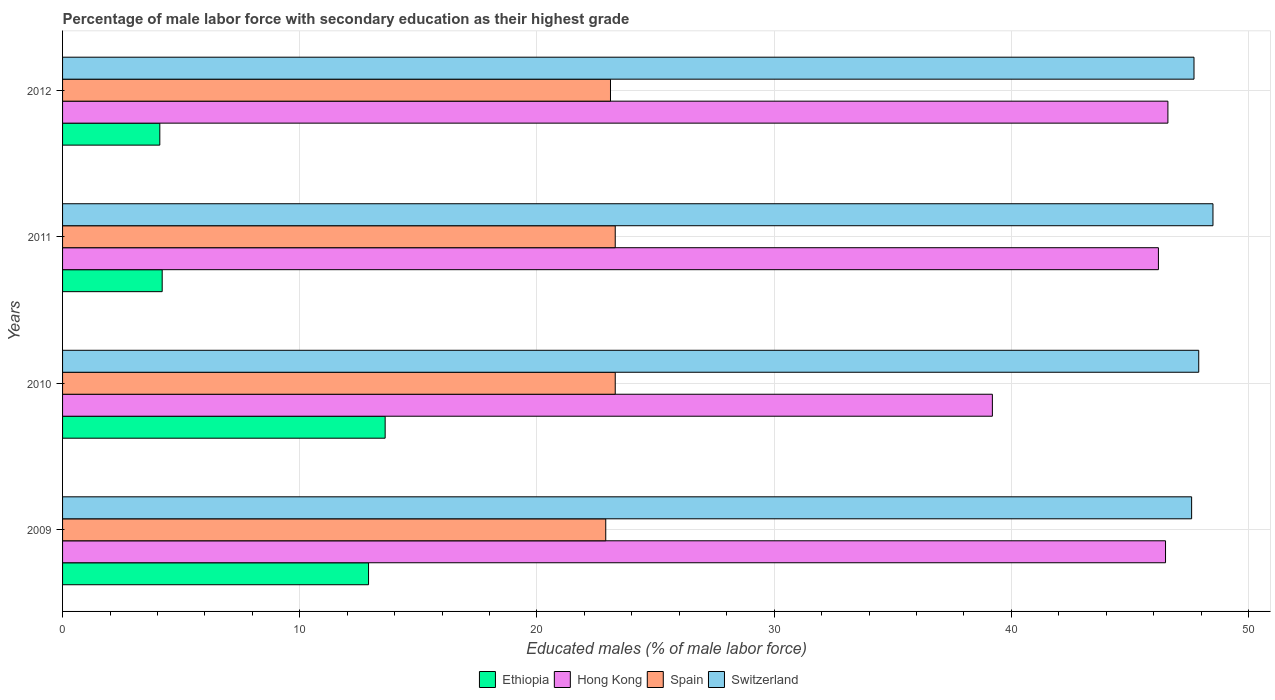How many different coloured bars are there?
Offer a very short reply. 4. Are the number of bars on each tick of the Y-axis equal?
Ensure brevity in your answer.  Yes. How many bars are there on the 4th tick from the top?
Give a very brief answer. 4. What is the label of the 3rd group of bars from the top?
Keep it short and to the point. 2010. In how many cases, is the number of bars for a given year not equal to the number of legend labels?
Give a very brief answer. 0. What is the percentage of male labor force with secondary education in Ethiopia in 2011?
Give a very brief answer. 4.2. Across all years, what is the maximum percentage of male labor force with secondary education in Spain?
Offer a very short reply. 23.3. Across all years, what is the minimum percentage of male labor force with secondary education in Switzerland?
Keep it short and to the point. 47.6. In which year was the percentage of male labor force with secondary education in Hong Kong maximum?
Offer a terse response. 2012. In which year was the percentage of male labor force with secondary education in Switzerland minimum?
Provide a short and direct response. 2009. What is the total percentage of male labor force with secondary education in Ethiopia in the graph?
Keep it short and to the point. 34.8. What is the difference between the percentage of male labor force with secondary education in Ethiopia in 2009 and that in 2012?
Offer a very short reply. 8.8. What is the difference between the percentage of male labor force with secondary education in Ethiopia in 2011 and the percentage of male labor force with secondary education in Spain in 2012?
Offer a very short reply. -18.9. What is the average percentage of male labor force with secondary education in Hong Kong per year?
Keep it short and to the point. 44.63. In the year 2011, what is the difference between the percentage of male labor force with secondary education in Switzerland and percentage of male labor force with secondary education in Hong Kong?
Your answer should be compact. 2.3. What is the difference between the highest and the second highest percentage of male labor force with secondary education in Ethiopia?
Your answer should be compact. 0.7. What is the difference between the highest and the lowest percentage of male labor force with secondary education in Spain?
Offer a terse response. 0.4. In how many years, is the percentage of male labor force with secondary education in Spain greater than the average percentage of male labor force with secondary education in Spain taken over all years?
Provide a short and direct response. 2. Is it the case that in every year, the sum of the percentage of male labor force with secondary education in Ethiopia and percentage of male labor force with secondary education in Spain is greater than the sum of percentage of male labor force with secondary education in Hong Kong and percentage of male labor force with secondary education in Switzerland?
Make the answer very short. No. What does the 4th bar from the top in 2010 represents?
Provide a short and direct response. Ethiopia. Is it the case that in every year, the sum of the percentage of male labor force with secondary education in Hong Kong and percentage of male labor force with secondary education in Spain is greater than the percentage of male labor force with secondary education in Ethiopia?
Your response must be concise. Yes. How many bars are there?
Your answer should be very brief. 16. How many years are there in the graph?
Make the answer very short. 4. What is the difference between two consecutive major ticks on the X-axis?
Offer a very short reply. 10. Are the values on the major ticks of X-axis written in scientific E-notation?
Provide a short and direct response. No. Does the graph contain any zero values?
Your response must be concise. No. How many legend labels are there?
Your response must be concise. 4. How are the legend labels stacked?
Provide a short and direct response. Horizontal. What is the title of the graph?
Your answer should be compact. Percentage of male labor force with secondary education as their highest grade. What is the label or title of the X-axis?
Your answer should be compact. Educated males (% of male labor force). What is the label or title of the Y-axis?
Your response must be concise. Years. What is the Educated males (% of male labor force) of Ethiopia in 2009?
Offer a very short reply. 12.9. What is the Educated males (% of male labor force) of Hong Kong in 2009?
Make the answer very short. 46.5. What is the Educated males (% of male labor force) in Spain in 2009?
Offer a very short reply. 22.9. What is the Educated males (% of male labor force) in Switzerland in 2009?
Give a very brief answer. 47.6. What is the Educated males (% of male labor force) in Ethiopia in 2010?
Provide a succinct answer. 13.6. What is the Educated males (% of male labor force) of Hong Kong in 2010?
Your answer should be very brief. 39.2. What is the Educated males (% of male labor force) in Spain in 2010?
Provide a short and direct response. 23.3. What is the Educated males (% of male labor force) in Switzerland in 2010?
Your answer should be compact. 47.9. What is the Educated males (% of male labor force) in Ethiopia in 2011?
Offer a very short reply. 4.2. What is the Educated males (% of male labor force) in Hong Kong in 2011?
Your response must be concise. 46.2. What is the Educated males (% of male labor force) of Spain in 2011?
Your response must be concise. 23.3. What is the Educated males (% of male labor force) in Switzerland in 2011?
Your answer should be very brief. 48.5. What is the Educated males (% of male labor force) in Ethiopia in 2012?
Your answer should be very brief. 4.1. What is the Educated males (% of male labor force) of Hong Kong in 2012?
Your answer should be very brief. 46.6. What is the Educated males (% of male labor force) of Spain in 2012?
Your response must be concise. 23.1. What is the Educated males (% of male labor force) of Switzerland in 2012?
Give a very brief answer. 47.7. Across all years, what is the maximum Educated males (% of male labor force) in Ethiopia?
Your answer should be compact. 13.6. Across all years, what is the maximum Educated males (% of male labor force) in Hong Kong?
Offer a very short reply. 46.6. Across all years, what is the maximum Educated males (% of male labor force) in Spain?
Offer a very short reply. 23.3. Across all years, what is the maximum Educated males (% of male labor force) of Switzerland?
Make the answer very short. 48.5. Across all years, what is the minimum Educated males (% of male labor force) of Ethiopia?
Your response must be concise. 4.1. Across all years, what is the minimum Educated males (% of male labor force) in Hong Kong?
Give a very brief answer. 39.2. Across all years, what is the minimum Educated males (% of male labor force) in Spain?
Keep it short and to the point. 22.9. Across all years, what is the minimum Educated males (% of male labor force) of Switzerland?
Provide a succinct answer. 47.6. What is the total Educated males (% of male labor force) in Ethiopia in the graph?
Offer a very short reply. 34.8. What is the total Educated males (% of male labor force) in Hong Kong in the graph?
Your answer should be compact. 178.5. What is the total Educated males (% of male labor force) of Spain in the graph?
Ensure brevity in your answer.  92.6. What is the total Educated males (% of male labor force) of Switzerland in the graph?
Provide a succinct answer. 191.7. What is the difference between the Educated males (% of male labor force) of Ethiopia in 2009 and that in 2010?
Give a very brief answer. -0.7. What is the difference between the Educated males (% of male labor force) of Hong Kong in 2009 and that in 2010?
Your answer should be compact. 7.3. What is the difference between the Educated males (% of male labor force) in Switzerland in 2009 and that in 2010?
Offer a terse response. -0.3. What is the difference between the Educated males (% of male labor force) in Ethiopia in 2009 and that in 2011?
Make the answer very short. 8.7. What is the difference between the Educated males (% of male labor force) of Hong Kong in 2009 and that in 2011?
Your answer should be very brief. 0.3. What is the difference between the Educated males (% of male labor force) in Switzerland in 2009 and that in 2011?
Offer a very short reply. -0.9. What is the difference between the Educated males (% of male labor force) of Ethiopia in 2009 and that in 2012?
Keep it short and to the point. 8.8. What is the difference between the Educated males (% of male labor force) of Hong Kong in 2009 and that in 2012?
Ensure brevity in your answer.  -0.1. What is the difference between the Educated males (% of male labor force) of Switzerland in 2009 and that in 2012?
Make the answer very short. -0.1. What is the difference between the Educated males (% of male labor force) in Ethiopia in 2010 and that in 2011?
Keep it short and to the point. 9.4. What is the difference between the Educated males (% of male labor force) of Hong Kong in 2010 and that in 2011?
Your answer should be compact. -7. What is the difference between the Educated males (% of male labor force) in Spain in 2010 and that in 2011?
Make the answer very short. 0. What is the difference between the Educated males (% of male labor force) of Ethiopia in 2010 and that in 2012?
Keep it short and to the point. 9.5. What is the difference between the Educated males (% of male labor force) of Hong Kong in 2010 and that in 2012?
Your answer should be compact. -7.4. What is the difference between the Educated males (% of male labor force) in Spain in 2010 and that in 2012?
Provide a short and direct response. 0.2. What is the difference between the Educated males (% of male labor force) of Switzerland in 2010 and that in 2012?
Make the answer very short. 0.2. What is the difference between the Educated males (% of male labor force) in Spain in 2011 and that in 2012?
Keep it short and to the point. 0.2. What is the difference between the Educated males (% of male labor force) of Ethiopia in 2009 and the Educated males (% of male labor force) of Hong Kong in 2010?
Keep it short and to the point. -26.3. What is the difference between the Educated males (% of male labor force) in Ethiopia in 2009 and the Educated males (% of male labor force) in Spain in 2010?
Your answer should be compact. -10.4. What is the difference between the Educated males (% of male labor force) in Ethiopia in 2009 and the Educated males (% of male labor force) in Switzerland in 2010?
Offer a very short reply. -35. What is the difference between the Educated males (% of male labor force) in Hong Kong in 2009 and the Educated males (% of male labor force) in Spain in 2010?
Provide a short and direct response. 23.2. What is the difference between the Educated males (% of male labor force) of Hong Kong in 2009 and the Educated males (% of male labor force) of Switzerland in 2010?
Your answer should be compact. -1.4. What is the difference between the Educated males (% of male labor force) in Spain in 2009 and the Educated males (% of male labor force) in Switzerland in 2010?
Give a very brief answer. -25. What is the difference between the Educated males (% of male labor force) of Ethiopia in 2009 and the Educated males (% of male labor force) of Hong Kong in 2011?
Your answer should be very brief. -33.3. What is the difference between the Educated males (% of male labor force) of Ethiopia in 2009 and the Educated males (% of male labor force) of Spain in 2011?
Keep it short and to the point. -10.4. What is the difference between the Educated males (% of male labor force) in Ethiopia in 2009 and the Educated males (% of male labor force) in Switzerland in 2011?
Ensure brevity in your answer.  -35.6. What is the difference between the Educated males (% of male labor force) in Hong Kong in 2009 and the Educated males (% of male labor force) in Spain in 2011?
Make the answer very short. 23.2. What is the difference between the Educated males (% of male labor force) of Spain in 2009 and the Educated males (% of male labor force) of Switzerland in 2011?
Your answer should be very brief. -25.6. What is the difference between the Educated males (% of male labor force) of Ethiopia in 2009 and the Educated males (% of male labor force) of Hong Kong in 2012?
Offer a very short reply. -33.7. What is the difference between the Educated males (% of male labor force) in Ethiopia in 2009 and the Educated males (% of male labor force) in Spain in 2012?
Provide a short and direct response. -10.2. What is the difference between the Educated males (% of male labor force) of Ethiopia in 2009 and the Educated males (% of male labor force) of Switzerland in 2012?
Provide a short and direct response. -34.8. What is the difference between the Educated males (% of male labor force) of Hong Kong in 2009 and the Educated males (% of male labor force) of Spain in 2012?
Make the answer very short. 23.4. What is the difference between the Educated males (% of male labor force) of Spain in 2009 and the Educated males (% of male labor force) of Switzerland in 2012?
Offer a terse response. -24.8. What is the difference between the Educated males (% of male labor force) in Ethiopia in 2010 and the Educated males (% of male labor force) in Hong Kong in 2011?
Offer a terse response. -32.6. What is the difference between the Educated males (% of male labor force) in Ethiopia in 2010 and the Educated males (% of male labor force) in Switzerland in 2011?
Your response must be concise. -34.9. What is the difference between the Educated males (% of male labor force) of Hong Kong in 2010 and the Educated males (% of male labor force) of Spain in 2011?
Provide a short and direct response. 15.9. What is the difference between the Educated males (% of male labor force) in Hong Kong in 2010 and the Educated males (% of male labor force) in Switzerland in 2011?
Offer a very short reply. -9.3. What is the difference between the Educated males (% of male labor force) in Spain in 2010 and the Educated males (% of male labor force) in Switzerland in 2011?
Your answer should be compact. -25.2. What is the difference between the Educated males (% of male labor force) in Ethiopia in 2010 and the Educated males (% of male labor force) in Hong Kong in 2012?
Keep it short and to the point. -33. What is the difference between the Educated males (% of male labor force) of Ethiopia in 2010 and the Educated males (% of male labor force) of Switzerland in 2012?
Provide a short and direct response. -34.1. What is the difference between the Educated males (% of male labor force) of Hong Kong in 2010 and the Educated males (% of male labor force) of Spain in 2012?
Provide a short and direct response. 16.1. What is the difference between the Educated males (% of male labor force) in Hong Kong in 2010 and the Educated males (% of male labor force) in Switzerland in 2012?
Your answer should be compact. -8.5. What is the difference between the Educated males (% of male labor force) in Spain in 2010 and the Educated males (% of male labor force) in Switzerland in 2012?
Provide a short and direct response. -24.4. What is the difference between the Educated males (% of male labor force) in Ethiopia in 2011 and the Educated males (% of male labor force) in Hong Kong in 2012?
Provide a succinct answer. -42.4. What is the difference between the Educated males (% of male labor force) in Ethiopia in 2011 and the Educated males (% of male labor force) in Spain in 2012?
Provide a succinct answer. -18.9. What is the difference between the Educated males (% of male labor force) of Ethiopia in 2011 and the Educated males (% of male labor force) of Switzerland in 2012?
Offer a very short reply. -43.5. What is the difference between the Educated males (% of male labor force) of Hong Kong in 2011 and the Educated males (% of male labor force) of Spain in 2012?
Provide a succinct answer. 23.1. What is the difference between the Educated males (% of male labor force) of Spain in 2011 and the Educated males (% of male labor force) of Switzerland in 2012?
Your response must be concise. -24.4. What is the average Educated males (% of male labor force) in Ethiopia per year?
Ensure brevity in your answer.  8.7. What is the average Educated males (% of male labor force) of Hong Kong per year?
Make the answer very short. 44.62. What is the average Educated males (% of male labor force) of Spain per year?
Give a very brief answer. 23.15. What is the average Educated males (% of male labor force) in Switzerland per year?
Ensure brevity in your answer.  47.92. In the year 2009, what is the difference between the Educated males (% of male labor force) in Ethiopia and Educated males (% of male labor force) in Hong Kong?
Provide a short and direct response. -33.6. In the year 2009, what is the difference between the Educated males (% of male labor force) in Ethiopia and Educated males (% of male labor force) in Switzerland?
Offer a terse response. -34.7. In the year 2009, what is the difference between the Educated males (% of male labor force) in Hong Kong and Educated males (% of male labor force) in Spain?
Your answer should be very brief. 23.6. In the year 2009, what is the difference between the Educated males (% of male labor force) of Spain and Educated males (% of male labor force) of Switzerland?
Provide a succinct answer. -24.7. In the year 2010, what is the difference between the Educated males (% of male labor force) of Ethiopia and Educated males (% of male labor force) of Hong Kong?
Ensure brevity in your answer.  -25.6. In the year 2010, what is the difference between the Educated males (% of male labor force) in Ethiopia and Educated males (% of male labor force) in Spain?
Provide a short and direct response. -9.7. In the year 2010, what is the difference between the Educated males (% of male labor force) in Ethiopia and Educated males (% of male labor force) in Switzerland?
Your answer should be very brief. -34.3. In the year 2010, what is the difference between the Educated males (% of male labor force) in Spain and Educated males (% of male labor force) in Switzerland?
Offer a terse response. -24.6. In the year 2011, what is the difference between the Educated males (% of male labor force) in Ethiopia and Educated males (% of male labor force) in Hong Kong?
Ensure brevity in your answer.  -42. In the year 2011, what is the difference between the Educated males (% of male labor force) in Ethiopia and Educated males (% of male labor force) in Spain?
Offer a very short reply. -19.1. In the year 2011, what is the difference between the Educated males (% of male labor force) in Ethiopia and Educated males (% of male labor force) in Switzerland?
Your response must be concise. -44.3. In the year 2011, what is the difference between the Educated males (% of male labor force) of Hong Kong and Educated males (% of male labor force) of Spain?
Your answer should be compact. 22.9. In the year 2011, what is the difference between the Educated males (% of male labor force) in Spain and Educated males (% of male labor force) in Switzerland?
Offer a terse response. -25.2. In the year 2012, what is the difference between the Educated males (% of male labor force) of Ethiopia and Educated males (% of male labor force) of Hong Kong?
Provide a succinct answer. -42.5. In the year 2012, what is the difference between the Educated males (% of male labor force) in Ethiopia and Educated males (% of male labor force) in Switzerland?
Your answer should be very brief. -43.6. In the year 2012, what is the difference between the Educated males (% of male labor force) of Hong Kong and Educated males (% of male labor force) of Spain?
Your response must be concise. 23.5. In the year 2012, what is the difference between the Educated males (% of male labor force) of Spain and Educated males (% of male labor force) of Switzerland?
Keep it short and to the point. -24.6. What is the ratio of the Educated males (% of male labor force) in Ethiopia in 2009 to that in 2010?
Your answer should be compact. 0.95. What is the ratio of the Educated males (% of male labor force) of Hong Kong in 2009 to that in 2010?
Keep it short and to the point. 1.19. What is the ratio of the Educated males (% of male labor force) in Spain in 2009 to that in 2010?
Give a very brief answer. 0.98. What is the ratio of the Educated males (% of male labor force) of Ethiopia in 2009 to that in 2011?
Keep it short and to the point. 3.07. What is the ratio of the Educated males (% of male labor force) in Spain in 2009 to that in 2011?
Your answer should be compact. 0.98. What is the ratio of the Educated males (% of male labor force) in Switzerland in 2009 to that in 2011?
Keep it short and to the point. 0.98. What is the ratio of the Educated males (% of male labor force) of Ethiopia in 2009 to that in 2012?
Your answer should be very brief. 3.15. What is the ratio of the Educated males (% of male labor force) in Spain in 2009 to that in 2012?
Make the answer very short. 0.99. What is the ratio of the Educated males (% of male labor force) in Ethiopia in 2010 to that in 2011?
Give a very brief answer. 3.24. What is the ratio of the Educated males (% of male labor force) in Hong Kong in 2010 to that in 2011?
Offer a terse response. 0.85. What is the ratio of the Educated males (% of male labor force) in Spain in 2010 to that in 2011?
Make the answer very short. 1. What is the ratio of the Educated males (% of male labor force) of Switzerland in 2010 to that in 2011?
Offer a terse response. 0.99. What is the ratio of the Educated males (% of male labor force) of Ethiopia in 2010 to that in 2012?
Make the answer very short. 3.32. What is the ratio of the Educated males (% of male labor force) of Hong Kong in 2010 to that in 2012?
Your response must be concise. 0.84. What is the ratio of the Educated males (% of male labor force) of Spain in 2010 to that in 2012?
Offer a very short reply. 1.01. What is the ratio of the Educated males (% of male labor force) in Ethiopia in 2011 to that in 2012?
Your answer should be very brief. 1.02. What is the ratio of the Educated males (% of male labor force) of Hong Kong in 2011 to that in 2012?
Your answer should be compact. 0.99. What is the ratio of the Educated males (% of male labor force) in Spain in 2011 to that in 2012?
Keep it short and to the point. 1.01. What is the ratio of the Educated males (% of male labor force) in Switzerland in 2011 to that in 2012?
Offer a terse response. 1.02. What is the difference between the highest and the second highest Educated males (% of male labor force) of Spain?
Your answer should be very brief. 0. What is the difference between the highest and the second highest Educated males (% of male labor force) of Switzerland?
Keep it short and to the point. 0.6. What is the difference between the highest and the lowest Educated males (% of male labor force) of Ethiopia?
Keep it short and to the point. 9.5. What is the difference between the highest and the lowest Educated males (% of male labor force) in Hong Kong?
Offer a terse response. 7.4. What is the difference between the highest and the lowest Educated males (% of male labor force) in Switzerland?
Your answer should be very brief. 0.9. 